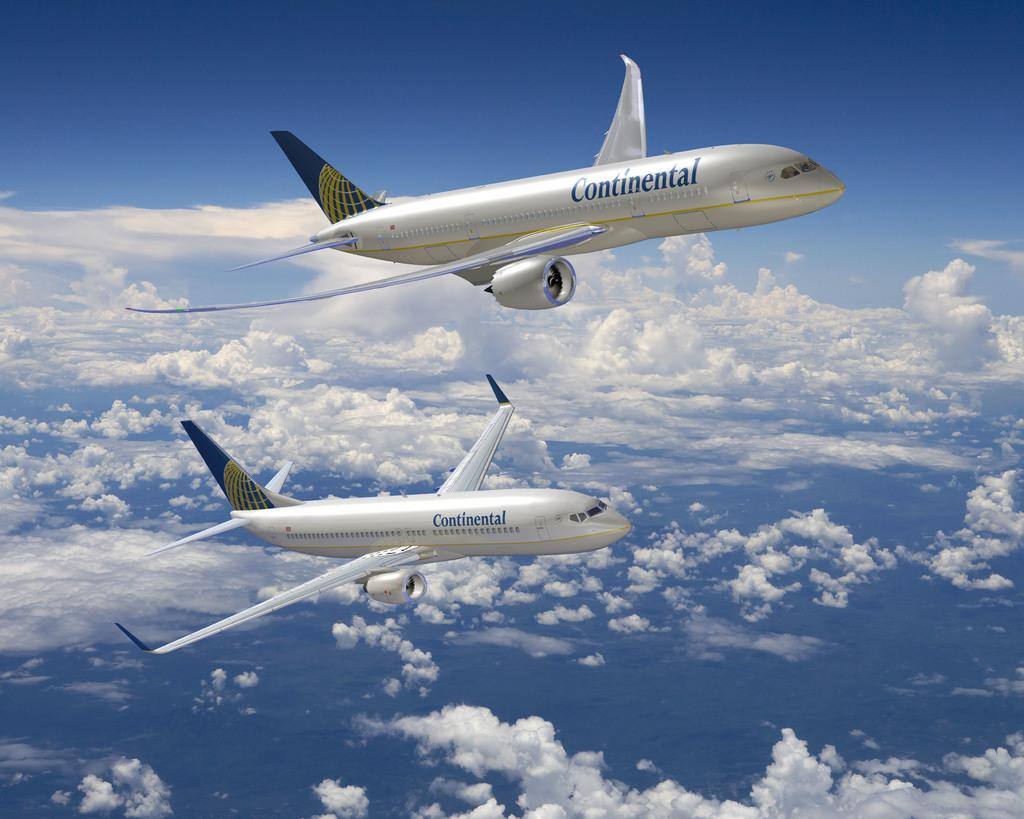How many airplanes are visible in the image? There are two airplanes in the image. What are the airplanes doing in the image? The airplanes are flying in the sky. Where is the cemetery located in the image? There is no cemetery present in the image. What type of lock can be seen securing the airplanes in the image? There is no lock present in the image; the airplanes are flying in the sky. 